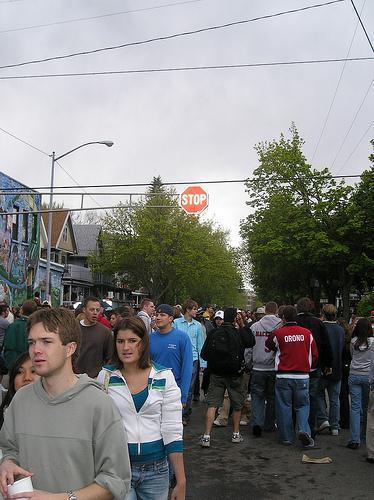How many people are holding cups?
Give a very brief answer. 1. 